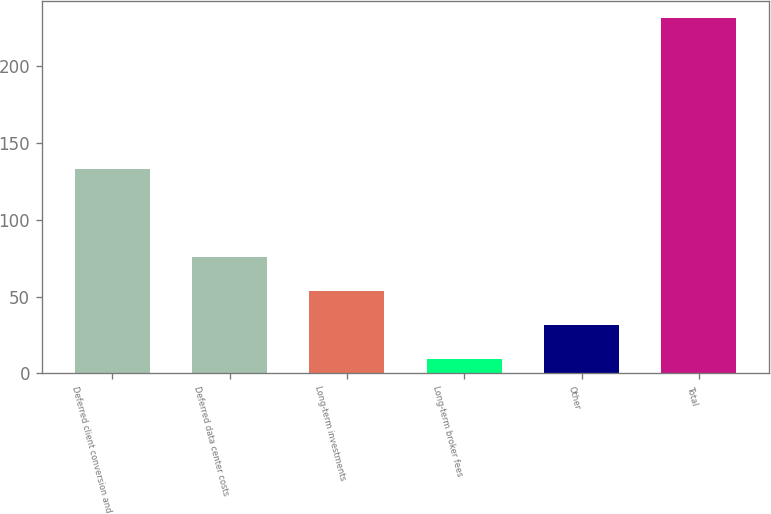<chart> <loc_0><loc_0><loc_500><loc_500><bar_chart><fcel>Deferred client conversion and<fcel>Deferred data center costs<fcel>Long-term investments<fcel>Long-term broker fees<fcel>Other<fcel>Total<nl><fcel>133.3<fcel>75.83<fcel>53.62<fcel>9.2<fcel>31.41<fcel>231.3<nl></chart> 